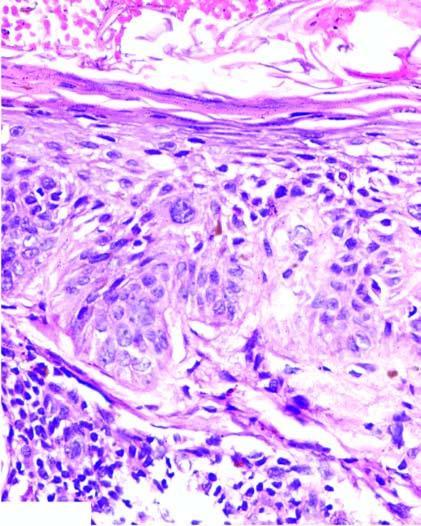what is thick with loss of rete ridges?
Answer the question using a single word or phrase. Epidermis 